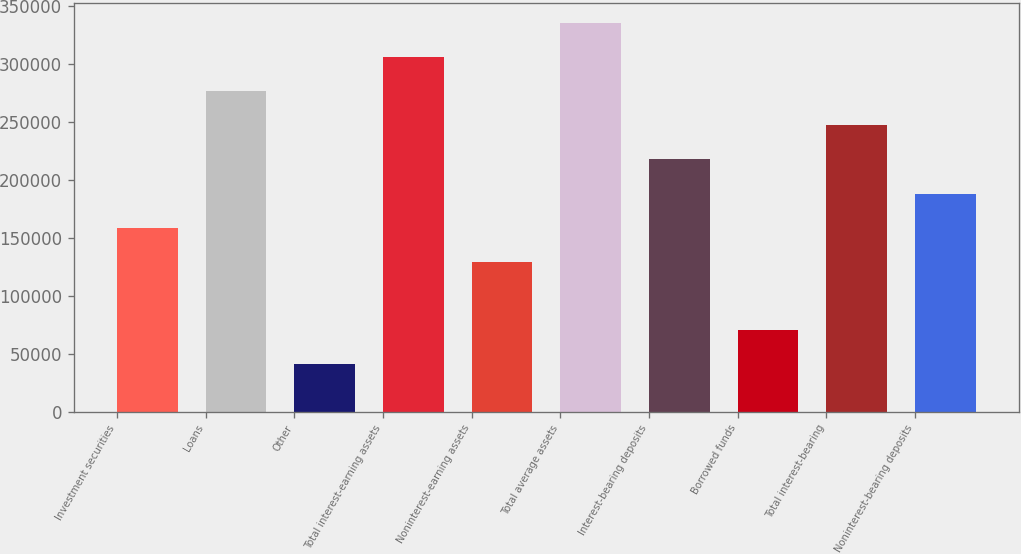Convert chart. <chart><loc_0><loc_0><loc_500><loc_500><bar_chart><fcel>Investment securities<fcel>Loans<fcel>Other<fcel>Total interest-earning assets<fcel>Noninterest-earning assets<fcel>Total average assets<fcel>Interest-bearing deposits<fcel>Borrowed funds<fcel>Total interest-bearing<fcel>Noninterest-bearing deposits<nl><fcel>158484<fcel>276310<fcel>40658.4<fcel>305766<fcel>129028<fcel>335222<fcel>217397<fcel>70114.8<fcel>246853<fcel>187940<nl></chart> 